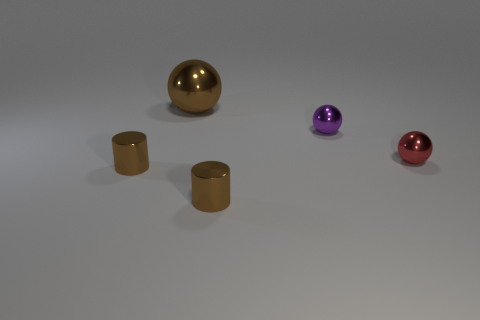Are there any small brown shiny things of the same shape as the red thing?
Ensure brevity in your answer.  No. What is the shape of the purple thing that is the same size as the red sphere?
Provide a short and direct response. Sphere. What material is the red ball?
Your response must be concise. Metal. What is the size of the brown shiny cylinder that is on the right side of the brown metal object behind the small sphere that is to the left of the small red object?
Offer a terse response. Small. What number of metal objects are big brown balls or small things?
Provide a succinct answer. 5. What size is the red thing?
Make the answer very short. Small. What number of things are either tiny yellow things or small things that are behind the tiny red sphere?
Your answer should be very brief. 1. What number of other things are the same color as the large ball?
Offer a terse response. 2. Do the red sphere and the thing that is to the left of the brown ball have the same size?
Offer a terse response. Yes. There is a metallic ball that is to the left of the purple thing; does it have the same size as the tiny purple object?
Your response must be concise. No. 